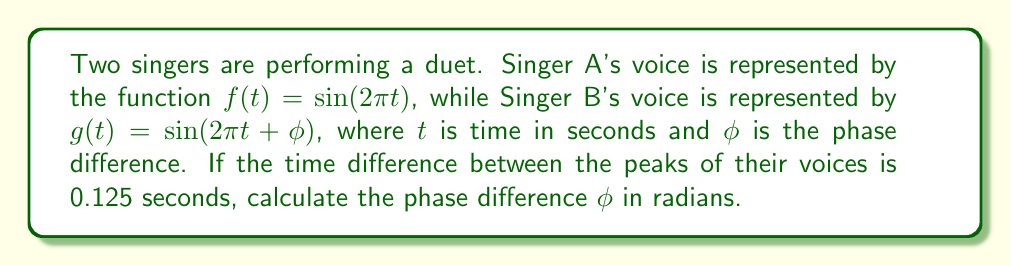Teach me how to tackle this problem. Let's approach this step-by-step:

1) The period of both functions is 1 second, as $f(t) = \sin(2\pi t)$ completes one full cycle when $2\pi t = 2\pi$, or when $t = 1$.

2) The time difference between peaks is 0.125 seconds, which is 1/8 of the total period.

3) In terms of a full cycle (2π radians), 1/8 of a cycle is:

   $$\phi = \frac{1}{8} \cdot 2\pi = \frac{\pi}{4}$$

4) We can verify this by considering the general formula for phase difference:

   $$\phi = 2\pi \cdot \frac{\text{time difference}}{\text{period}}$$

   $$\phi = 2\pi \cdot \frac{0.125}{1} = \frac{\pi}{4}$$

5) This phase difference represents how far ahead Singer A is compared to Singer B. If we wanted to express how far Singer B is behind Singer A, we would use $-\frac{\pi}{4}$.
Answer: $\frac{\pi}{4}$ radians 